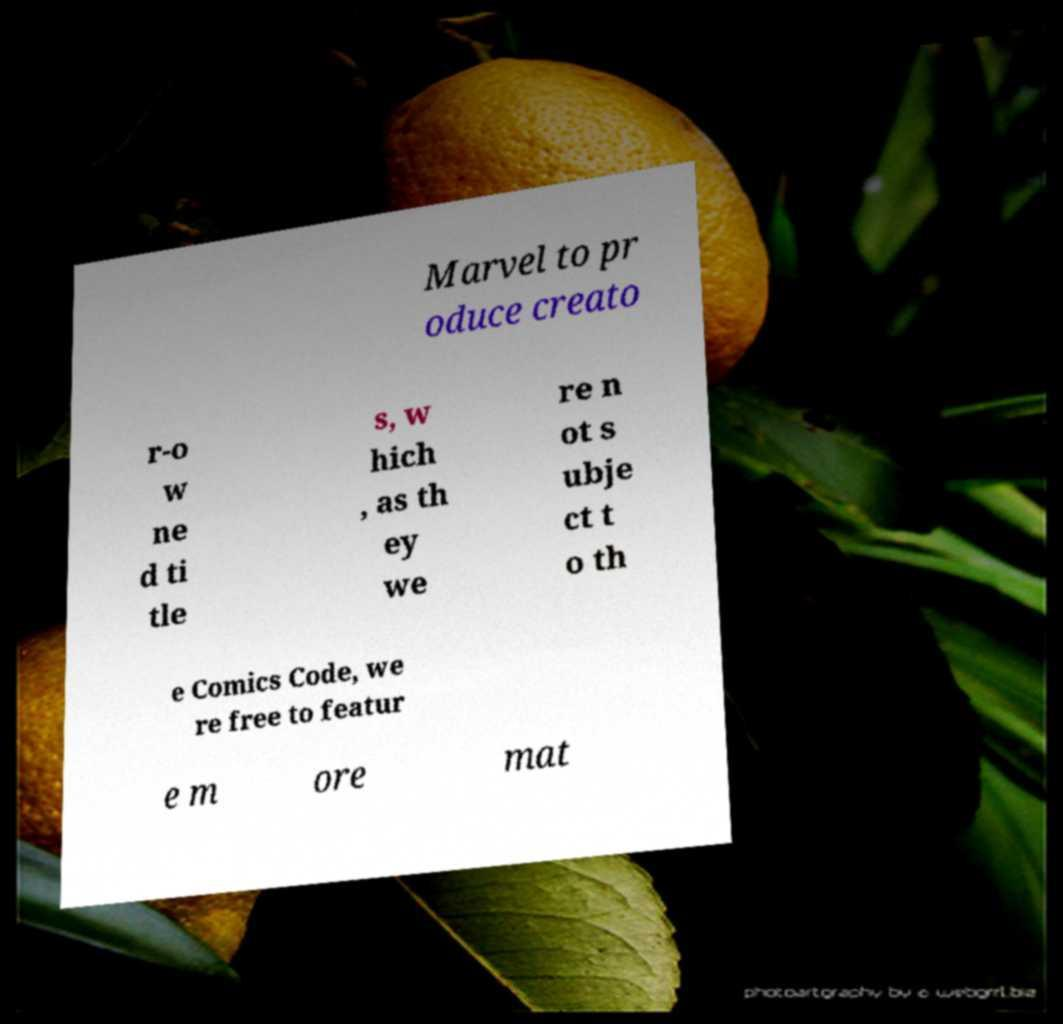What messages or text are displayed in this image? I need them in a readable, typed format. Marvel to pr oduce creato r-o w ne d ti tle s, w hich , as th ey we re n ot s ubje ct t o th e Comics Code, we re free to featur e m ore mat 